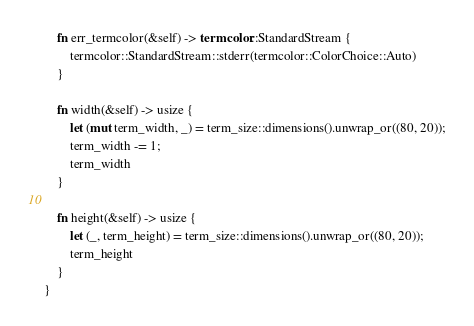<code> <loc_0><loc_0><loc_500><loc_500><_Rust_>
    fn err_termcolor(&self) -> termcolor::StandardStream {
        termcolor::StandardStream::stderr(termcolor::ColorChoice::Auto)
    }

    fn width(&self) -> usize {
        let (mut term_width, _) = term_size::dimensions().unwrap_or((80, 20));
        term_width -= 1;
        term_width
    }

    fn height(&self) -> usize {
        let (_, term_height) = term_size::dimensions().unwrap_or((80, 20));
        term_height
    }
}
</code> 